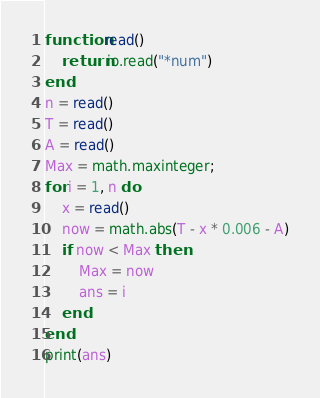Convert code to text. <code><loc_0><loc_0><loc_500><loc_500><_Lua_>function read()
    return io.read("*num")
end
n = read()
T = read()
A = read()
Max = math.maxinteger;
for i = 1, n do
    x = read()
    now = math.abs(T - x * 0.006 - A)
    if now < Max then
        Max = now
        ans = i
    end
end
print(ans)

</code> 